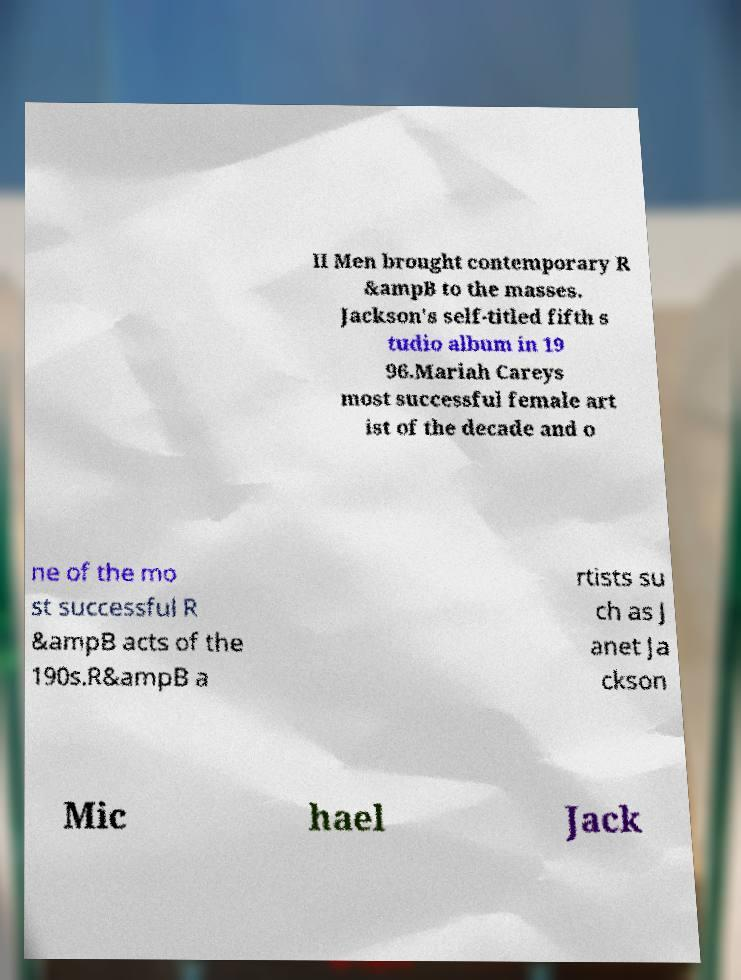There's text embedded in this image that I need extracted. Can you transcribe it verbatim? II Men brought contemporary R &ampB to the masses. Jackson's self-titled fifth s tudio album in 19 96.Mariah Careys most successful female art ist of the decade and o ne of the mo st successful R &ampB acts of the 190s.R&ampB a rtists su ch as J anet Ja ckson Mic hael Jack 